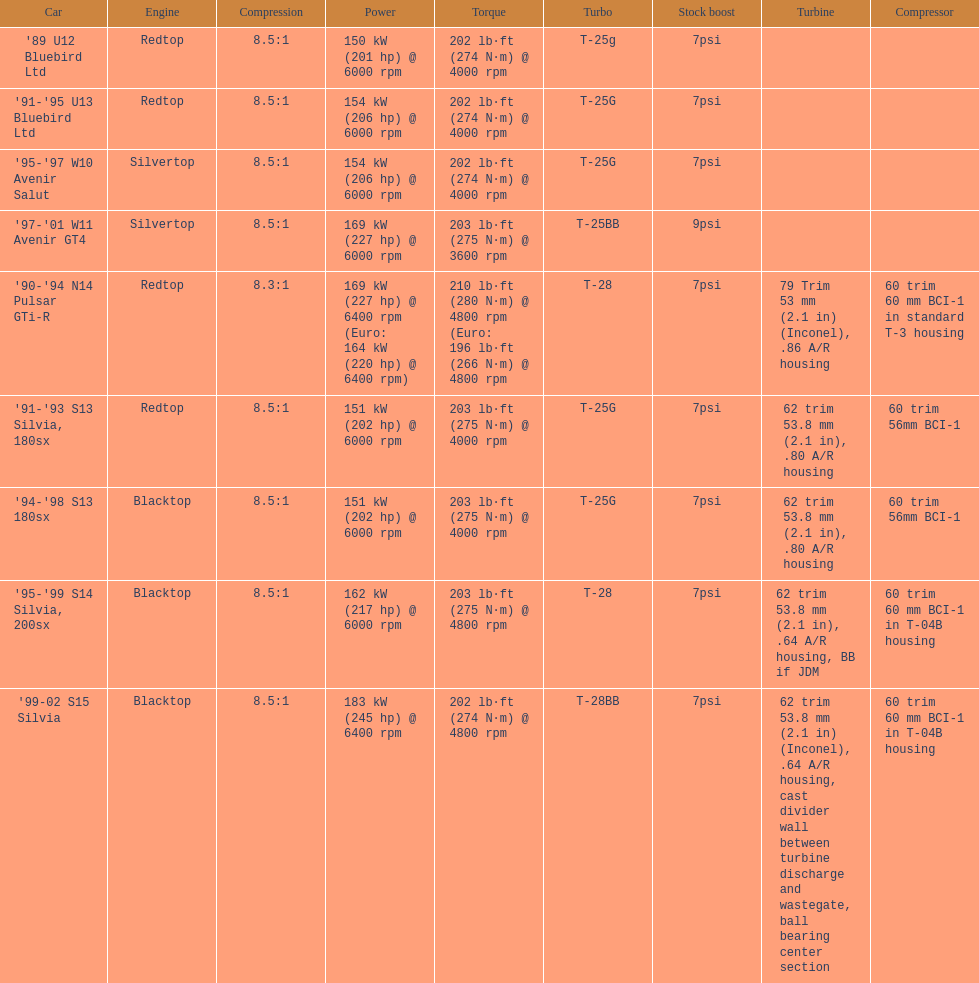Which automobile comes with a standard boost exceeding 7psi? '97-'01 W11 Avenir GT4. 